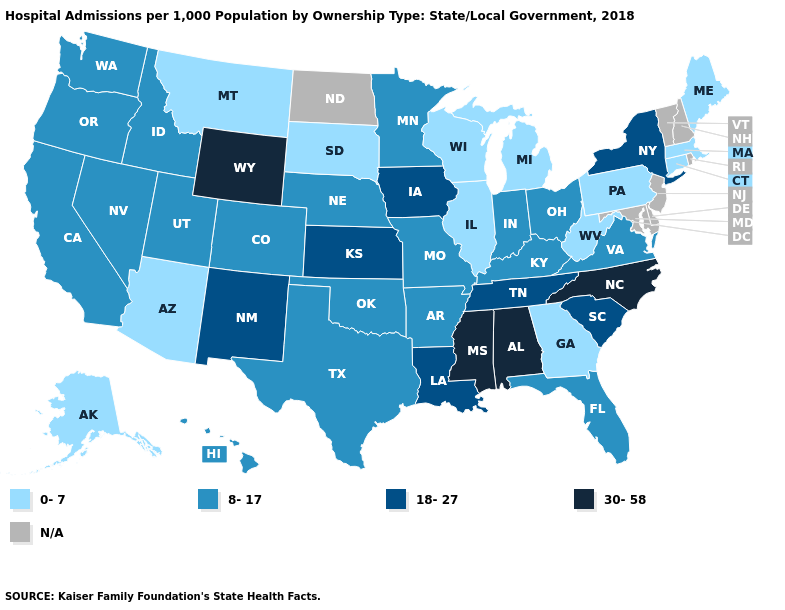Among the states that border South Dakota , which have the highest value?
Answer briefly. Wyoming. Name the states that have a value in the range 8-17?
Answer briefly. Arkansas, California, Colorado, Florida, Hawaii, Idaho, Indiana, Kentucky, Minnesota, Missouri, Nebraska, Nevada, Ohio, Oklahoma, Oregon, Texas, Utah, Virginia, Washington. Which states hav the highest value in the MidWest?
Be succinct. Iowa, Kansas. Name the states that have a value in the range N/A?
Short answer required. Delaware, Maryland, New Hampshire, New Jersey, North Dakota, Rhode Island, Vermont. Name the states that have a value in the range 0-7?
Write a very short answer. Alaska, Arizona, Connecticut, Georgia, Illinois, Maine, Massachusetts, Michigan, Montana, Pennsylvania, South Dakota, West Virginia, Wisconsin. Name the states that have a value in the range 0-7?
Write a very short answer. Alaska, Arizona, Connecticut, Georgia, Illinois, Maine, Massachusetts, Michigan, Montana, Pennsylvania, South Dakota, West Virginia, Wisconsin. Among the states that border Kentucky , does Ohio have the lowest value?
Keep it brief. No. What is the value of Virginia?
Short answer required. 8-17. What is the value of Rhode Island?
Write a very short answer. N/A. What is the highest value in the West ?
Keep it brief. 30-58. Name the states that have a value in the range 0-7?
Keep it brief. Alaska, Arizona, Connecticut, Georgia, Illinois, Maine, Massachusetts, Michigan, Montana, Pennsylvania, South Dakota, West Virginia, Wisconsin. What is the highest value in states that border Georgia?
Be succinct. 30-58. Name the states that have a value in the range 18-27?
Answer briefly. Iowa, Kansas, Louisiana, New Mexico, New York, South Carolina, Tennessee. Does Wisconsin have the lowest value in the MidWest?
Be succinct. Yes. Is the legend a continuous bar?
Quick response, please. No. 